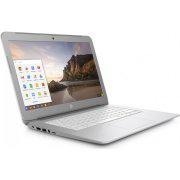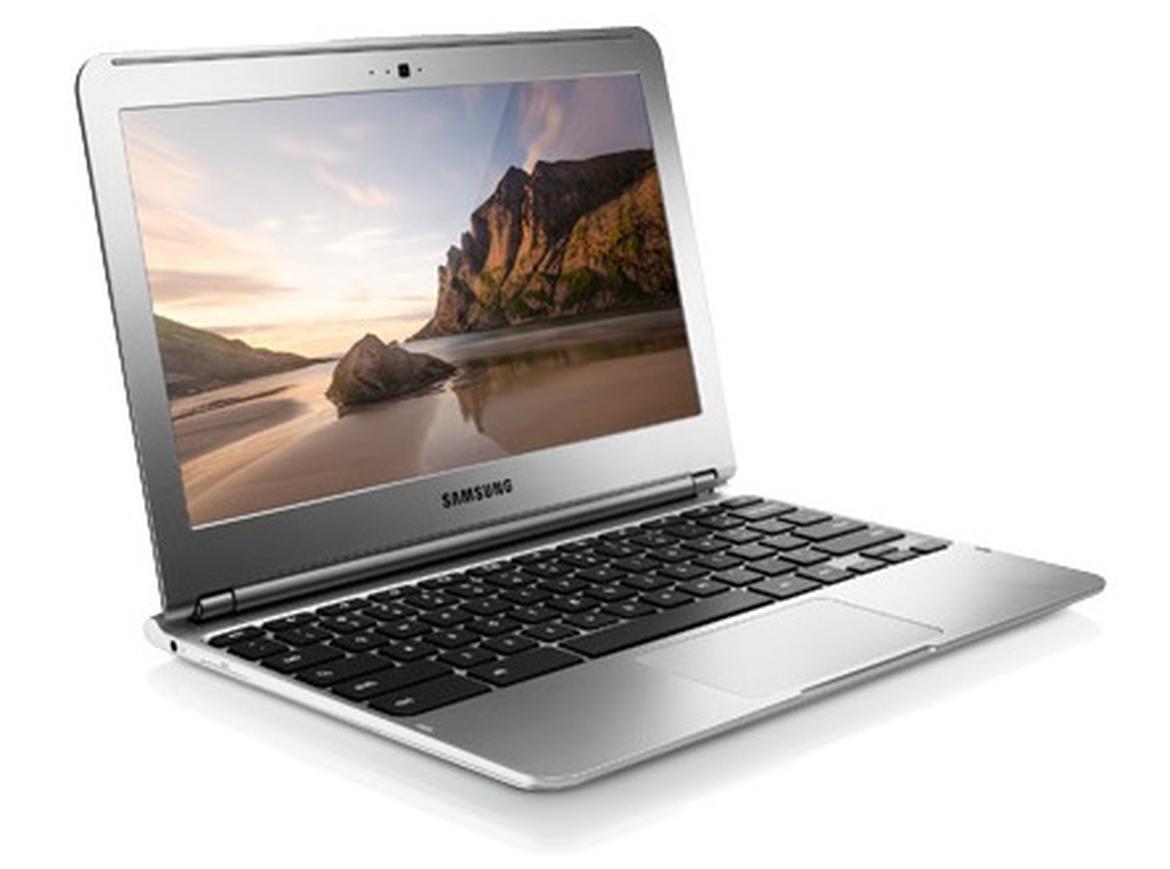The first image is the image on the left, the second image is the image on the right. Examine the images to the left and right. Is the description "In at least one image there is a laptop facing front right with a white box on the screen." accurate? Answer yes or no. Yes. The first image is the image on the left, the second image is the image on the right. Considering the images on both sides, is "Each image shows one laptop open to at least 90-degrees and displaying a landscape with sky, and the laptops on the left and right face the same general direction." valid? Answer yes or no. Yes. 